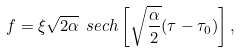Convert formula to latex. <formula><loc_0><loc_0><loc_500><loc_500>f = \xi \sqrt { 2 \alpha } \ s e c h \left [ \sqrt { \frac { \alpha } { 2 } } ( \tau - \tau _ { 0 } ) \right ] ,</formula> 